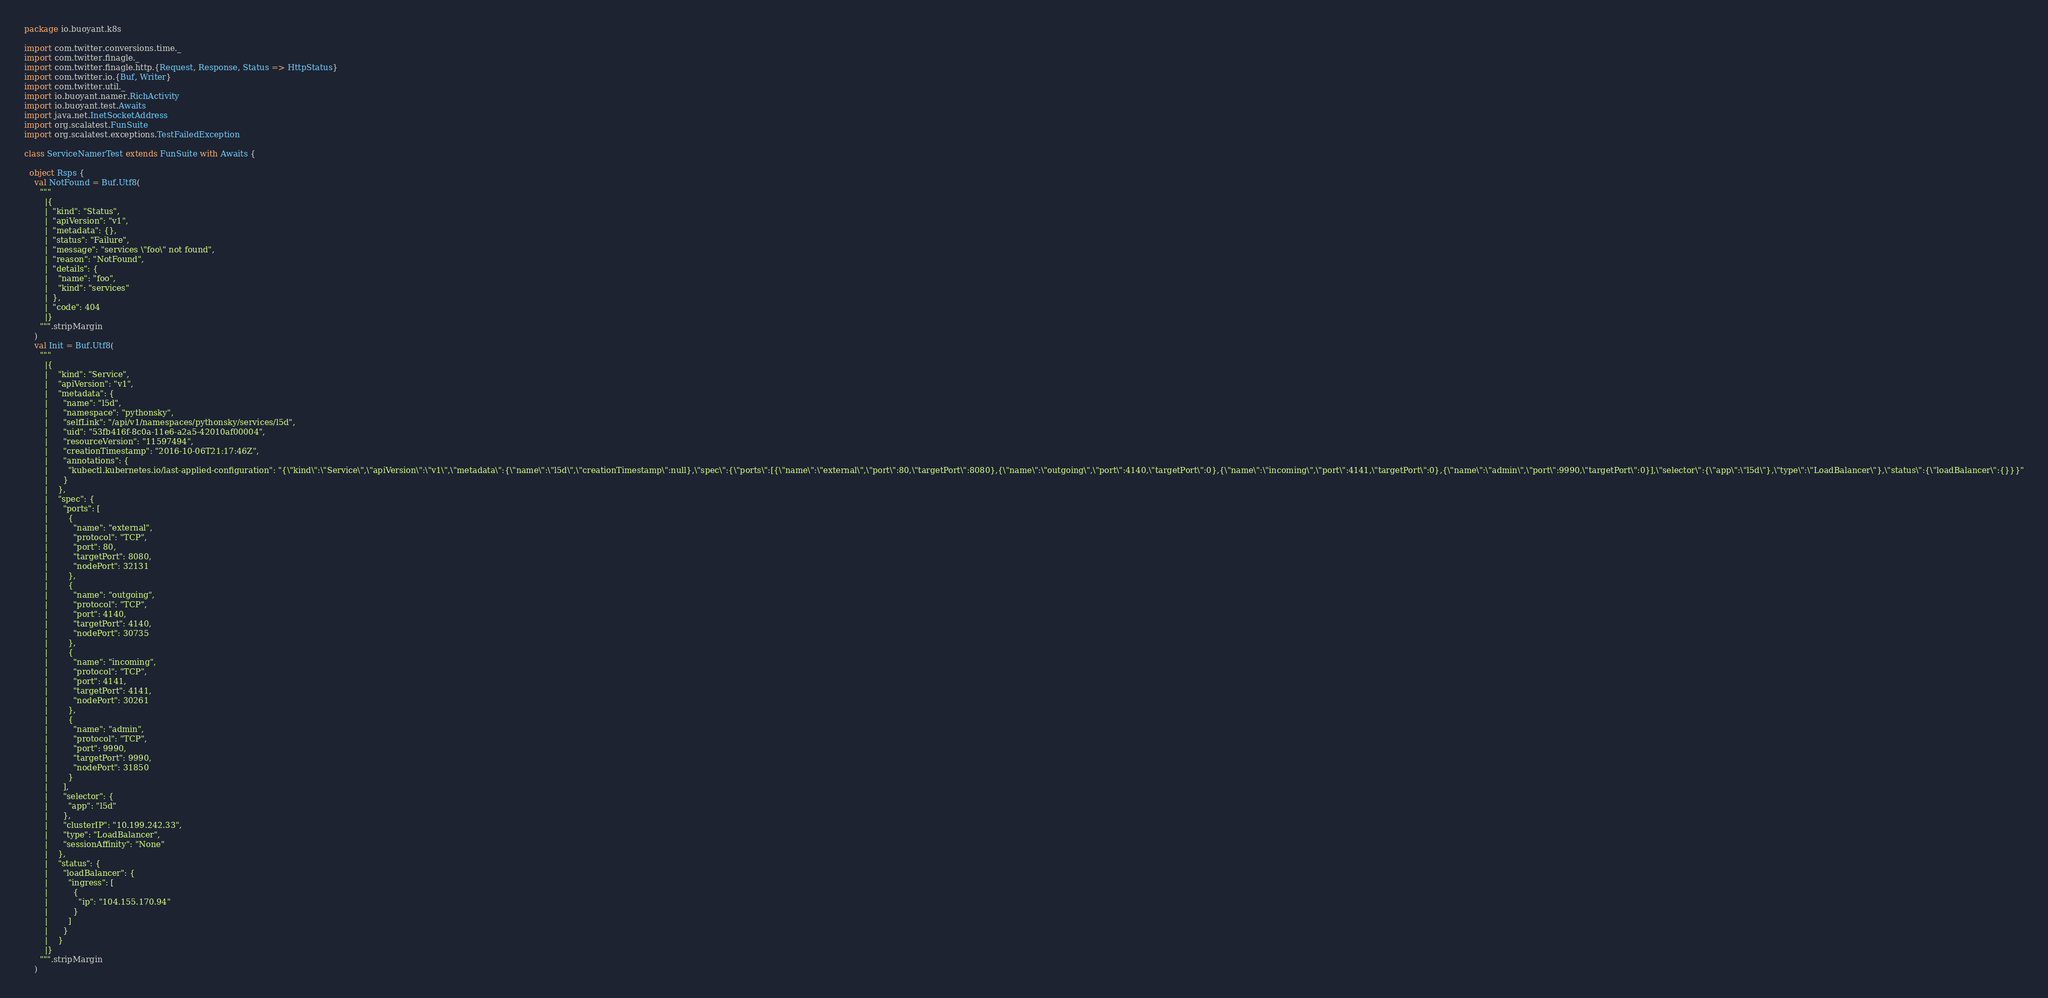Convert code to text. <code><loc_0><loc_0><loc_500><loc_500><_Scala_>package io.buoyant.k8s

import com.twitter.conversions.time._
import com.twitter.finagle._
import com.twitter.finagle.http.{Request, Response, Status => HttpStatus}
import com.twitter.io.{Buf, Writer}
import com.twitter.util._
import io.buoyant.namer.RichActivity
import io.buoyant.test.Awaits
import java.net.InetSocketAddress
import org.scalatest.FunSuite
import org.scalatest.exceptions.TestFailedException

class ServiceNamerTest extends FunSuite with Awaits {

  object Rsps {
    val NotFound = Buf.Utf8(
      """
        |{
        |  "kind": "Status",
        |  "apiVersion": "v1",
        |  "metadata": {},
        |  "status": "Failure",
        |  "message": "services \"foo\" not found",
        |  "reason": "NotFound",
        |  "details": {
        |    "name": "foo",
        |    "kind": "services"
        |  },
        |  "code": 404
        |}
      """.stripMargin
    )
    val Init = Buf.Utf8(
      """
        |{
        |    "kind": "Service",
        |    "apiVersion": "v1",
        |    "metadata": {
        |      "name": "l5d",
        |      "namespace": "pythonsky",
        |      "selfLink": "/api/v1/namespaces/pythonsky/services/l5d",
        |      "uid": "53fb416f-8c0a-11e6-a2a5-42010af00004",
        |      "resourceVersion": "11597494",
        |      "creationTimestamp": "2016-10-06T21:17:46Z",
        |      "annotations": {
        |        "kubectl.kubernetes.io/last-applied-configuration": "{\"kind\":\"Service\",\"apiVersion\":\"v1\",\"metadata\":{\"name\":\"l5d\",\"creationTimestamp\":null},\"spec\":{\"ports\":[{\"name\":\"external\",\"port\":80,\"targetPort\":8080},{\"name\":\"outgoing\",\"port\":4140,\"targetPort\":0},{\"name\":\"incoming\",\"port\":4141,\"targetPort\":0},{\"name\":\"admin\",\"port\":9990,\"targetPort\":0}],\"selector\":{\"app\":\"l5d\"},\"type\":\"LoadBalancer\"},\"status\":{\"loadBalancer\":{}}}"
        |      }
        |    },
        |    "spec": {
        |      "ports": [
        |        {
        |          "name": "external",
        |          "protocol": "TCP",
        |          "port": 80,
        |          "targetPort": 8080,
        |          "nodePort": 32131
        |        },
        |        {
        |          "name": "outgoing",
        |          "protocol": "TCP",
        |          "port": 4140,
        |          "targetPort": 4140,
        |          "nodePort": 30735
        |        },
        |        {
        |          "name": "incoming",
        |          "protocol": "TCP",
        |          "port": 4141,
        |          "targetPort": 4141,
        |          "nodePort": 30261
        |        },
        |        {
        |          "name": "admin",
        |          "protocol": "TCP",
        |          "port": 9990,
        |          "targetPort": 9990,
        |          "nodePort": 31850
        |        }
        |      ],
        |      "selector": {
        |        "app": "l5d"
        |      },
        |      "clusterIP": "10.199.242.33",
        |      "type": "LoadBalancer",
        |      "sessionAffinity": "None"
        |    },
        |    "status": {
        |      "loadBalancer": {
        |        "ingress": [
        |          {
        |            "ip": "104.155.170.94"
        |          }
        |        ]
        |      }
        |    }
        |}
      """.stripMargin
    )</code> 